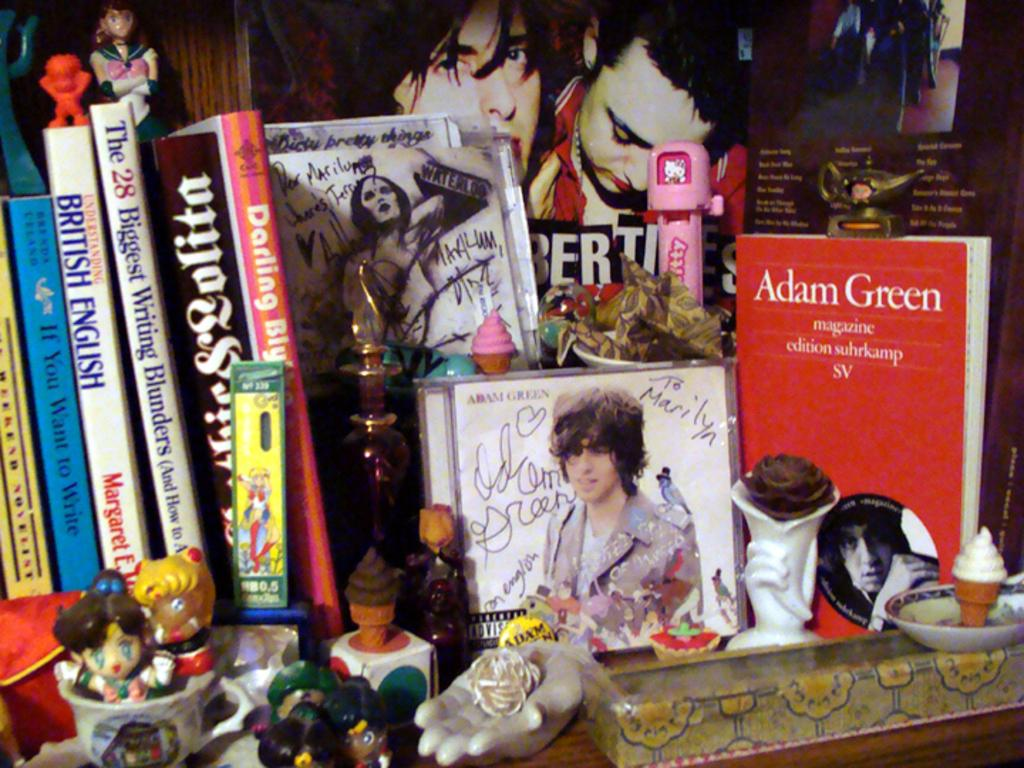<image>
Give a short and clear explanation of the subsequent image. Several books are here, including "Adam Green Magazine." 